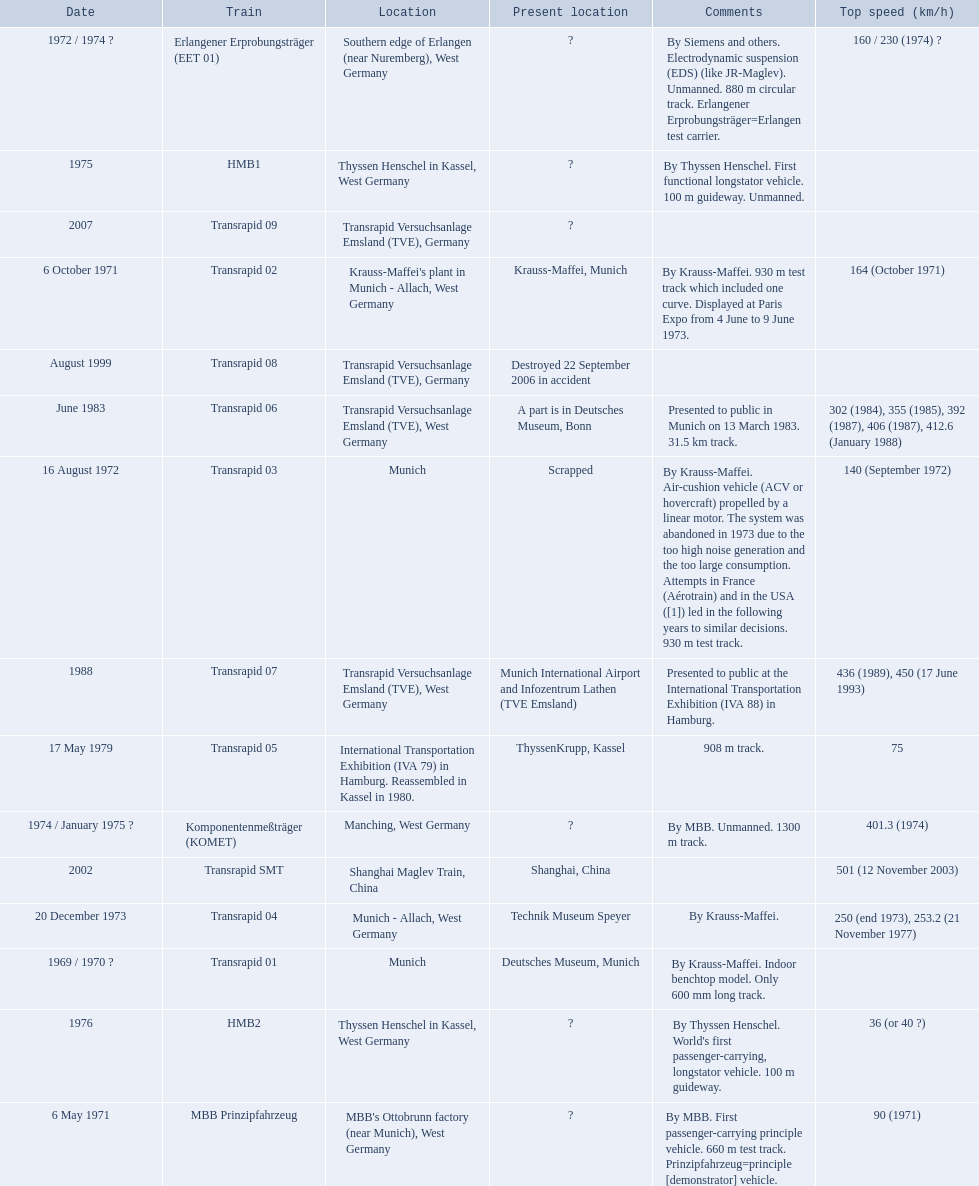What are all trains? Transrapid 01, MBB Prinzipfahrzeug, Transrapid 02, Transrapid 03, Erlangener Erprobungsträger (EET 01), Transrapid 04, Komponentenmeßträger (KOMET), HMB1, HMB2, Transrapid 05, Transrapid 06, Transrapid 07, Transrapid 08, Transrapid SMT, Transrapid 09. Which of all location of trains are known? Deutsches Museum, Munich, Krauss-Maffei, Munich, Scrapped, Technik Museum Speyer, ThyssenKrupp, Kassel, A part is in Deutsches Museum, Bonn, Munich International Airport and Infozentrum Lathen (TVE Emsland), Destroyed 22 September 2006 in accident, Shanghai, China. Which of those trains were scrapped? Transrapid 03. 